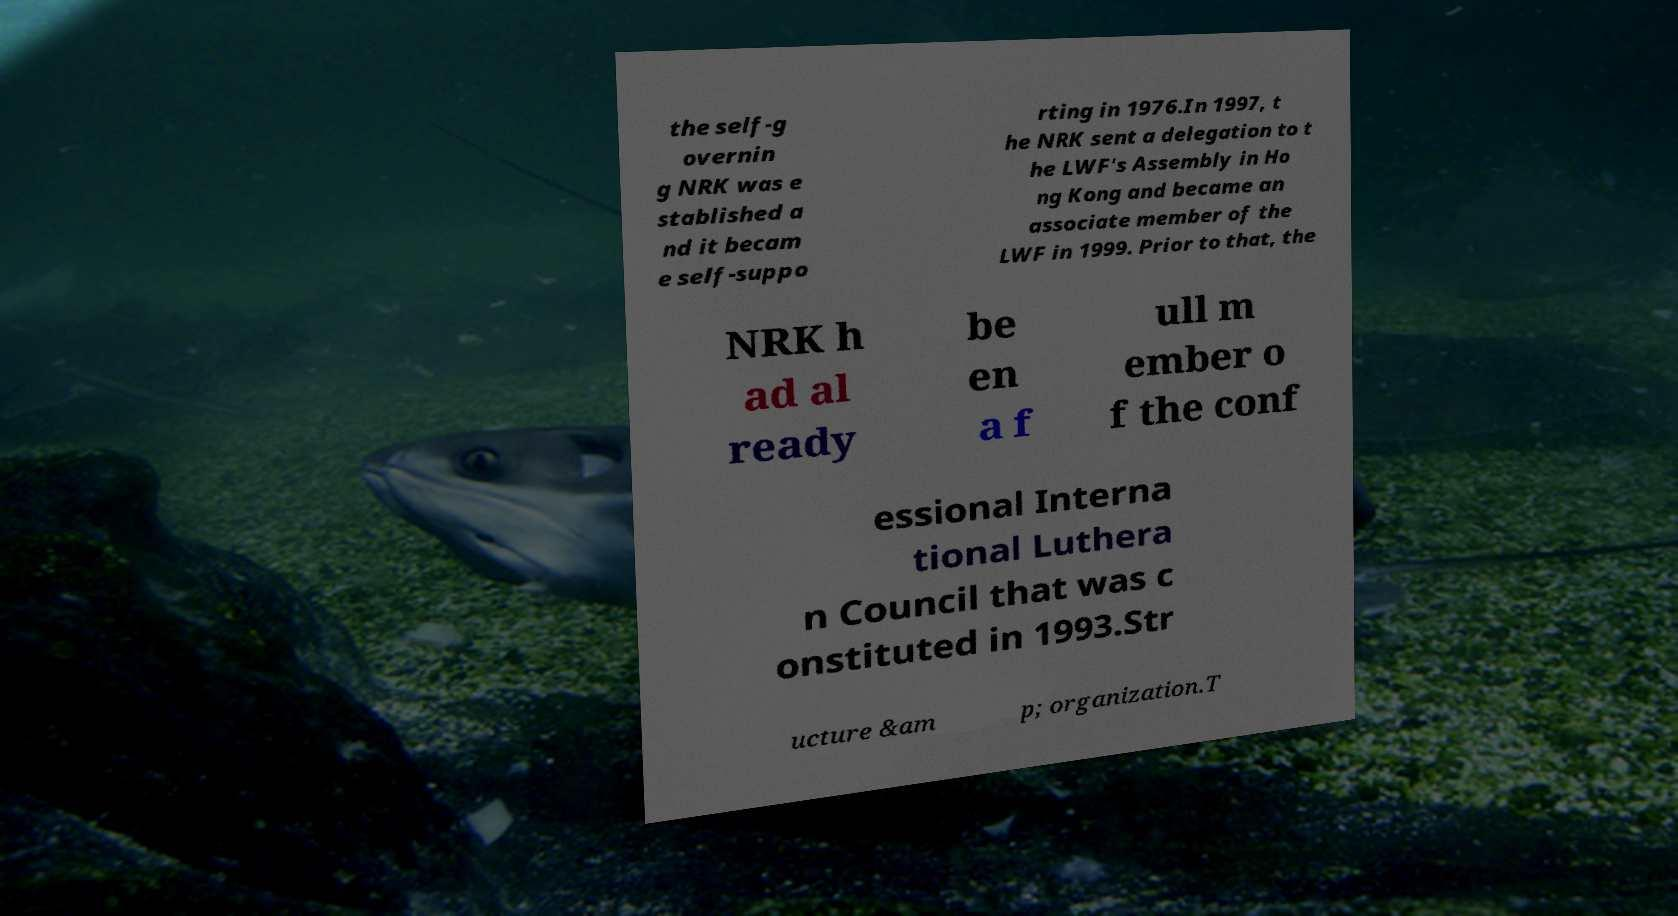Could you assist in decoding the text presented in this image and type it out clearly? the self-g overnin g NRK was e stablished a nd it becam e self-suppo rting in 1976.In 1997, t he NRK sent a delegation to t he LWF's Assembly in Ho ng Kong and became an associate member of the LWF in 1999. Prior to that, the NRK h ad al ready be en a f ull m ember o f the conf essional Interna tional Luthera n Council that was c onstituted in 1993.Str ucture &am p; organization.T 